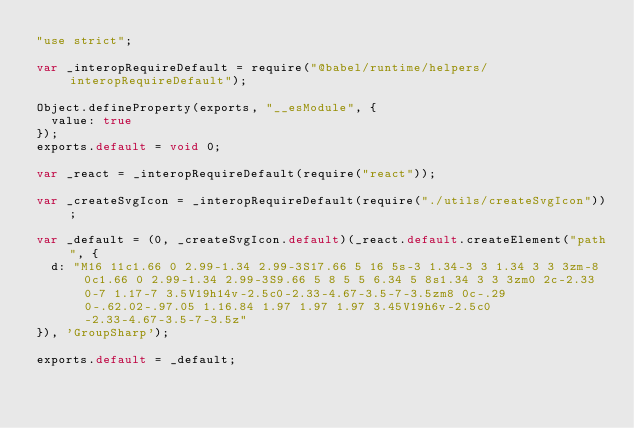Convert code to text. <code><loc_0><loc_0><loc_500><loc_500><_JavaScript_>"use strict";

var _interopRequireDefault = require("@babel/runtime/helpers/interopRequireDefault");

Object.defineProperty(exports, "__esModule", {
  value: true
});
exports.default = void 0;

var _react = _interopRequireDefault(require("react"));

var _createSvgIcon = _interopRequireDefault(require("./utils/createSvgIcon"));

var _default = (0, _createSvgIcon.default)(_react.default.createElement("path", {
  d: "M16 11c1.66 0 2.99-1.34 2.99-3S17.66 5 16 5s-3 1.34-3 3 1.34 3 3 3zm-8 0c1.66 0 2.99-1.34 2.99-3S9.66 5 8 5 5 6.34 5 8s1.34 3 3 3zm0 2c-2.33 0-7 1.17-7 3.5V19h14v-2.5c0-2.33-4.67-3.5-7-3.5zm8 0c-.29 0-.62.02-.97.05 1.16.84 1.97 1.97 1.97 3.45V19h6v-2.5c0-2.33-4.67-3.5-7-3.5z"
}), 'GroupSharp');

exports.default = _default;</code> 